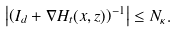Convert formula to latex. <formula><loc_0><loc_0><loc_500><loc_500>\left | \left ( I _ { d } + \nabla H _ { t } ( x , z ) \right ) ^ { - 1 } \right | \leq N _ { \kappa } .</formula> 